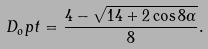<formula> <loc_0><loc_0><loc_500><loc_500>D _ { o } p t = \frac { 4 - \sqrt { 1 4 + 2 \cos 8 \alpha } } { 8 } .</formula> 